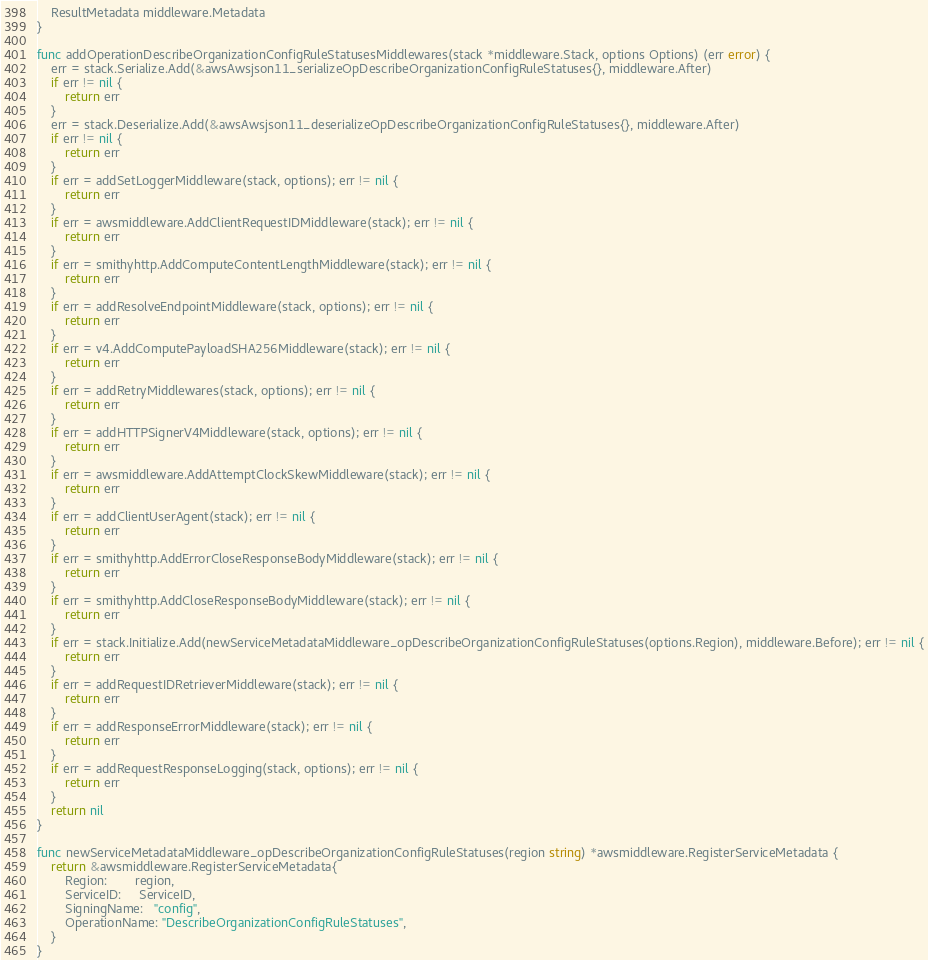<code> <loc_0><loc_0><loc_500><loc_500><_Go_>	ResultMetadata middleware.Metadata
}

func addOperationDescribeOrganizationConfigRuleStatusesMiddlewares(stack *middleware.Stack, options Options) (err error) {
	err = stack.Serialize.Add(&awsAwsjson11_serializeOpDescribeOrganizationConfigRuleStatuses{}, middleware.After)
	if err != nil {
		return err
	}
	err = stack.Deserialize.Add(&awsAwsjson11_deserializeOpDescribeOrganizationConfigRuleStatuses{}, middleware.After)
	if err != nil {
		return err
	}
	if err = addSetLoggerMiddleware(stack, options); err != nil {
		return err
	}
	if err = awsmiddleware.AddClientRequestIDMiddleware(stack); err != nil {
		return err
	}
	if err = smithyhttp.AddComputeContentLengthMiddleware(stack); err != nil {
		return err
	}
	if err = addResolveEndpointMiddleware(stack, options); err != nil {
		return err
	}
	if err = v4.AddComputePayloadSHA256Middleware(stack); err != nil {
		return err
	}
	if err = addRetryMiddlewares(stack, options); err != nil {
		return err
	}
	if err = addHTTPSignerV4Middleware(stack, options); err != nil {
		return err
	}
	if err = awsmiddleware.AddAttemptClockSkewMiddleware(stack); err != nil {
		return err
	}
	if err = addClientUserAgent(stack); err != nil {
		return err
	}
	if err = smithyhttp.AddErrorCloseResponseBodyMiddleware(stack); err != nil {
		return err
	}
	if err = smithyhttp.AddCloseResponseBodyMiddleware(stack); err != nil {
		return err
	}
	if err = stack.Initialize.Add(newServiceMetadataMiddleware_opDescribeOrganizationConfigRuleStatuses(options.Region), middleware.Before); err != nil {
		return err
	}
	if err = addRequestIDRetrieverMiddleware(stack); err != nil {
		return err
	}
	if err = addResponseErrorMiddleware(stack); err != nil {
		return err
	}
	if err = addRequestResponseLogging(stack, options); err != nil {
		return err
	}
	return nil
}

func newServiceMetadataMiddleware_opDescribeOrganizationConfigRuleStatuses(region string) *awsmiddleware.RegisterServiceMetadata {
	return &awsmiddleware.RegisterServiceMetadata{
		Region:        region,
		ServiceID:     ServiceID,
		SigningName:   "config",
		OperationName: "DescribeOrganizationConfigRuleStatuses",
	}
}
</code> 